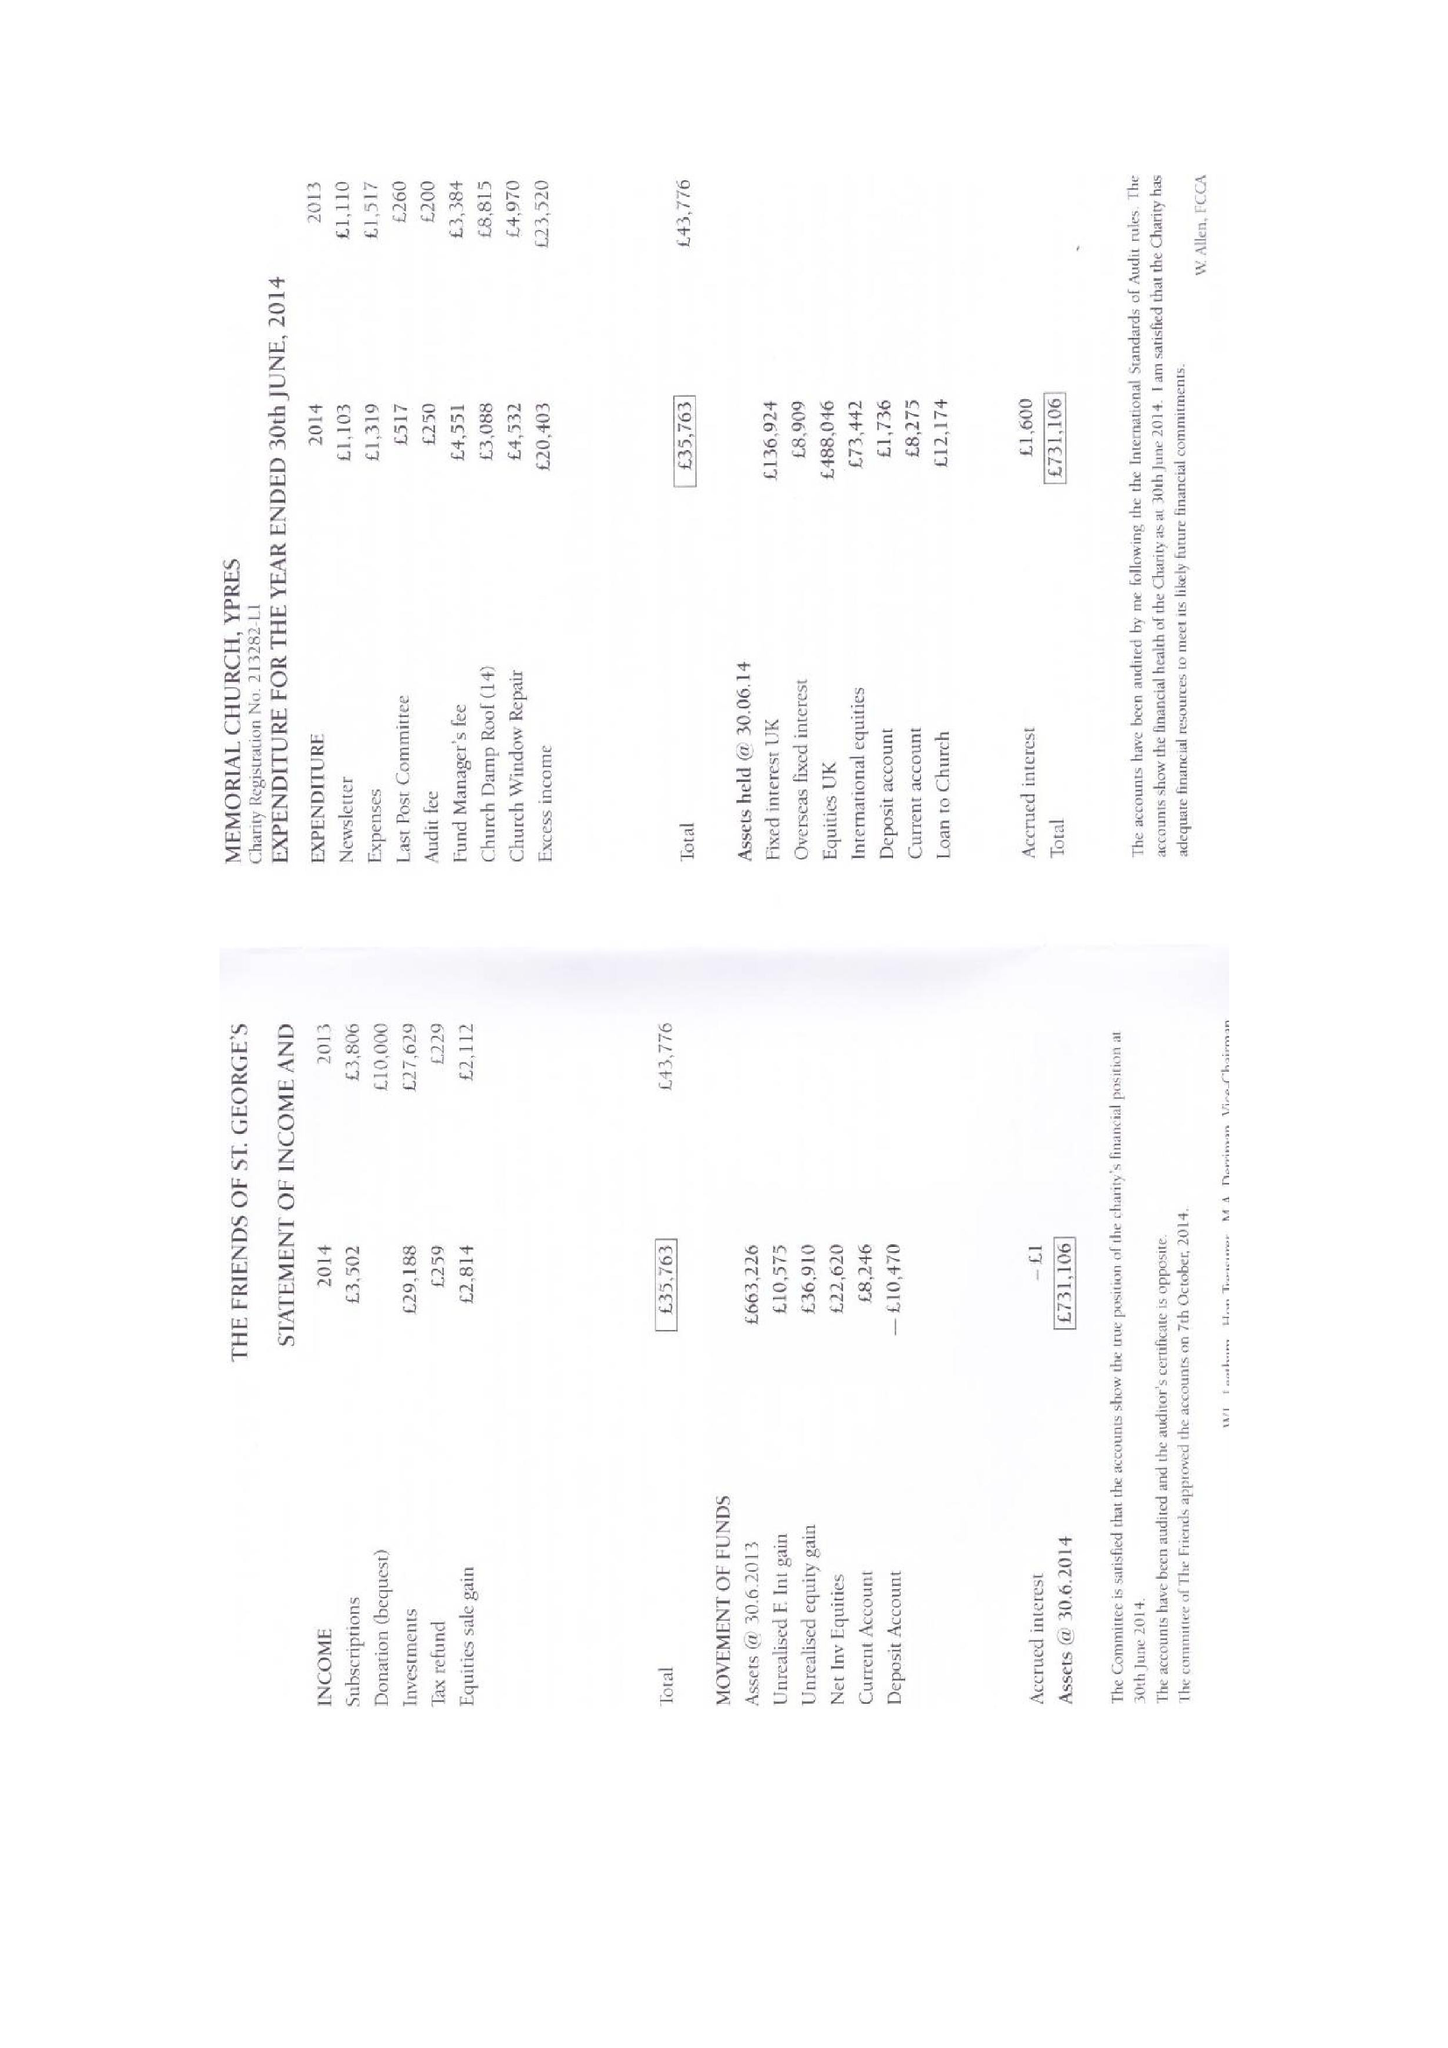What is the value for the charity_number?
Answer the question using a single word or phrase. 213282 